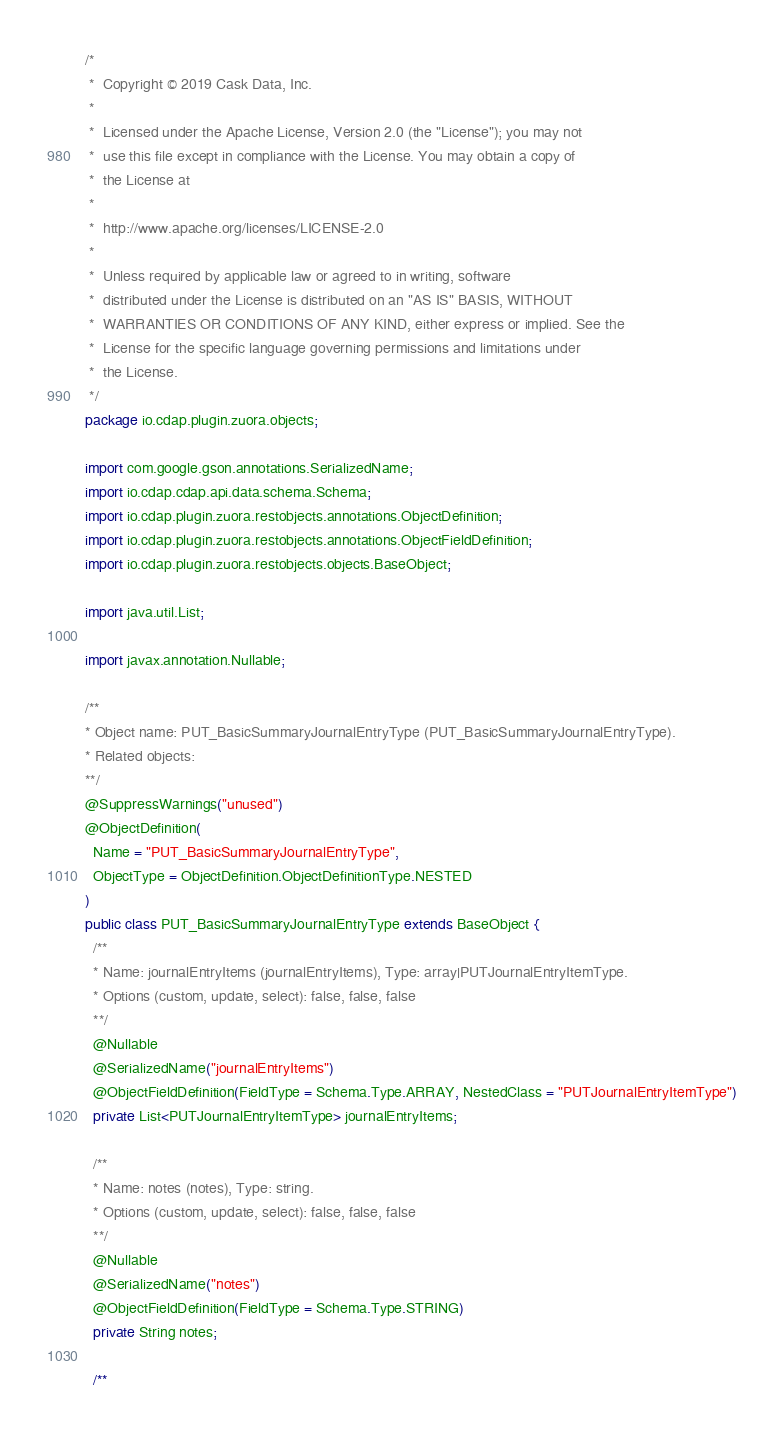<code> <loc_0><loc_0><loc_500><loc_500><_Java_>/*
 *  Copyright © 2019 Cask Data, Inc.
 *
 *  Licensed under the Apache License, Version 2.0 (the "License"); you may not
 *  use this file except in compliance with the License. You may obtain a copy of
 *  the License at
 *
 *  http://www.apache.org/licenses/LICENSE-2.0
 *
 *  Unless required by applicable law or agreed to in writing, software
 *  distributed under the License is distributed on an "AS IS" BASIS, WITHOUT
 *  WARRANTIES OR CONDITIONS OF ANY KIND, either express or implied. See the
 *  License for the specific language governing permissions and limitations under
 *  the License.
 */
package io.cdap.plugin.zuora.objects;

import com.google.gson.annotations.SerializedName;
import io.cdap.cdap.api.data.schema.Schema;
import io.cdap.plugin.zuora.restobjects.annotations.ObjectDefinition;
import io.cdap.plugin.zuora.restobjects.annotations.ObjectFieldDefinition;
import io.cdap.plugin.zuora.restobjects.objects.BaseObject;

import java.util.List;

import javax.annotation.Nullable;

/**
* Object name: PUT_BasicSummaryJournalEntryType (PUT_BasicSummaryJournalEntryType).
* Related objects:
**/
@SuppressWarnings("unused")
@ObjectDefinition(
  Name = "PUT_BasicSummaryJournalEntryType",
  ObjectType = ObjectDefinition.ObjectDefinitionType.NESTED
)
public class PUT_BasicSummaryJournalEntryType extends BaseObject {
  /**
  * Name: journalEntryItems (journalEntryItems), Type: array|PUTJournalEntryItemType.
  * Options (custom, update, select): false, false, false
  **/
  @Nullable
  @SerializedName("journalEntryItems")
  @ObjectFieldDefinition(FieldType = Schema.Type.ARRAY, NestedClass = "PUTJournalEntryItemType")
  private List<PUTJournalEntryItemType> journalEntryItems;

  /**
  * Name: notes (notes), Type: string.
  * Options (custom, update, select): false, false, false
  **/
  @Nullable
  @SerializedName("notes")
  @ObjectFieldDefinition(FieldType = Schema.Type.STRING)
  private String notes;

  /**</code> 